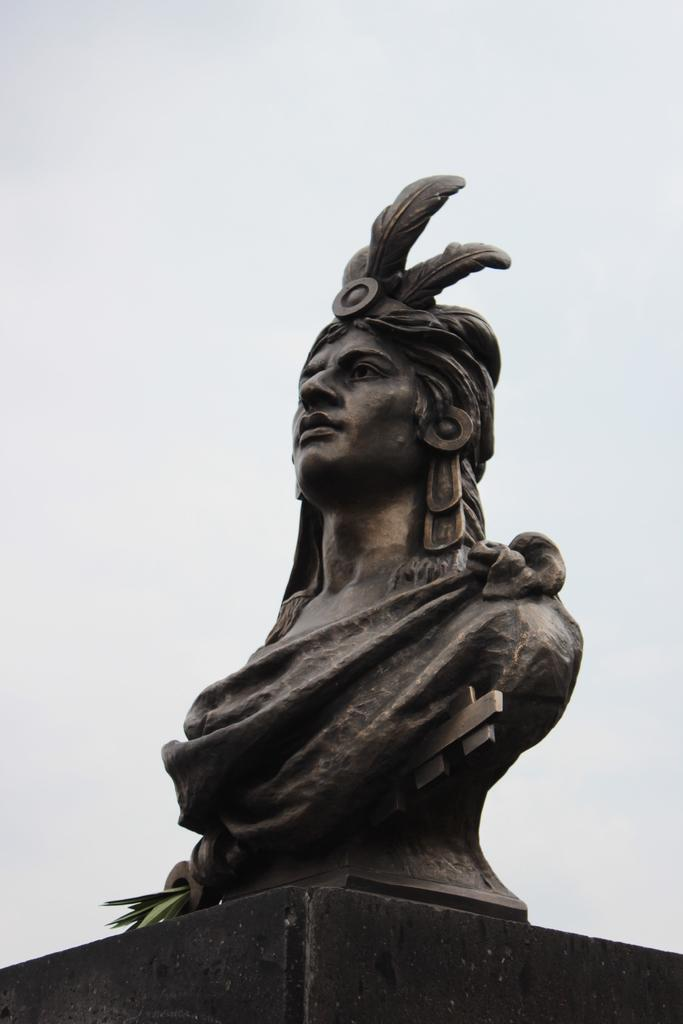What is the main subject in the image? There is a statue in the image. What else can be seen in the image besides the statue? There are leaves visible in the image. What is visible in the background of the image? The sky is visible in the background of the image. How many boys are sitting on the statue in the image? There are no boys present in the image; it features a statue and leaves. What is the statue's interest in the image? The statue does not have any interests, as it is an inanimate object. 